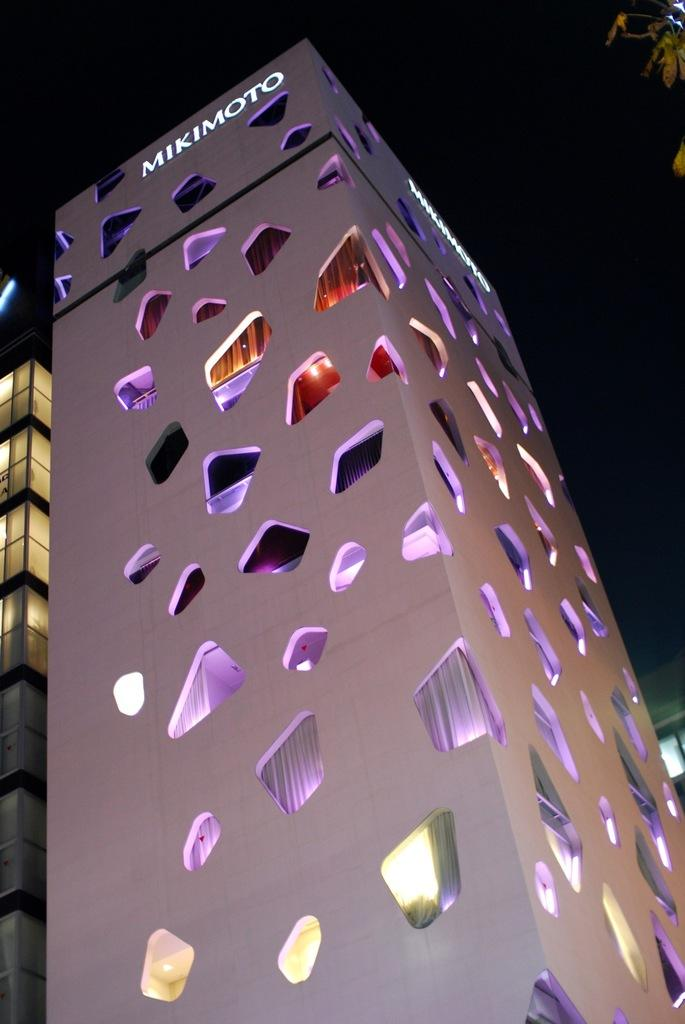What structures are located in the foreground of the image? There are two buildings in the foreground of the image. What can be observed about the sky in the image? The sky is dark in the top part of the image. Where is the tree located in the image? There is a tree in the top right corner of the image. What type of belief is depicted in the image? There is no depiction of a belief in the image; it features two buildings, a dark sky, and a tree. Can you see a train passing by in the image? There is no train present in the image. 